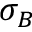Convert formula to latex. <formula><loc_0><loc_0><loc_500><loc_500>\sigma _ { B }</formula> 